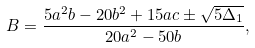<formula> <loc_0><loc_0><loc_500><loc_500>B = \frac { 5 a ^ { 2 } b - 2 0 b ^ { 2 } + 1 5 a c \pm \sqrt { 5 \Delta _ { 1 } } } { 2 0 a ^ { 2 } - 5 0 b } ,</formula> 